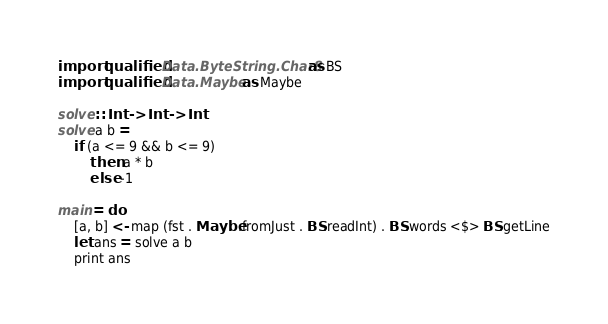<code> <loc_0><loc_0><loc_500><loc_500><_Haskell_>import qualified Data.ByteString.Char8 as BS
import qualified Data.Maybe as Maybe

solve :: Int -> Int -> Int
solve a b =
    if (a <= 9 && b <= 9)
        then a * b
        else -1

main = do
    [a, b] <- map (fst . Maybe.fromJust . BS.readInt) . BS.words <$> BS.getLine
    let ans = solve a b
    print ans</code> 